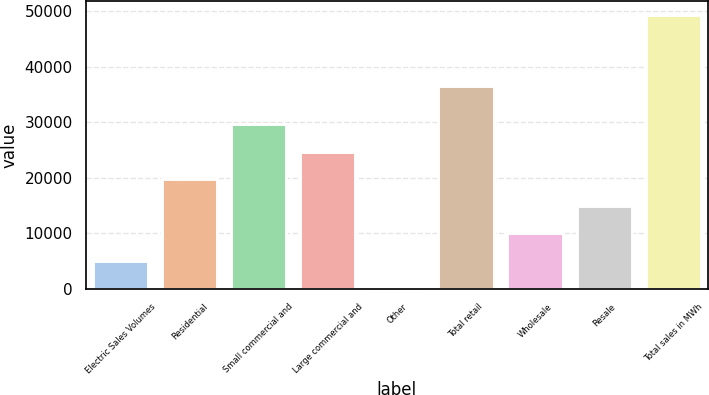Convert chart to OTSL. <chart><loc_0><loc_0><loc_500><loc_500><bar_chart><fcel>Electric Sales Volumes<fcel>Residential<fcel>Small commercial and<fcel>Large commercial and<fcel>Other<fcel>Total retail<fcel>Wholesale<fcel>Resale<fcel>Total sales in MWh<nl><fcel>5091.47<fcel>19839.1<fcel>29670.8<fcel>24755<fcel>175.6<fcel>36566<fcel>10007.3<fcel>14923.2<fcel>49334.3<nl></chart> 